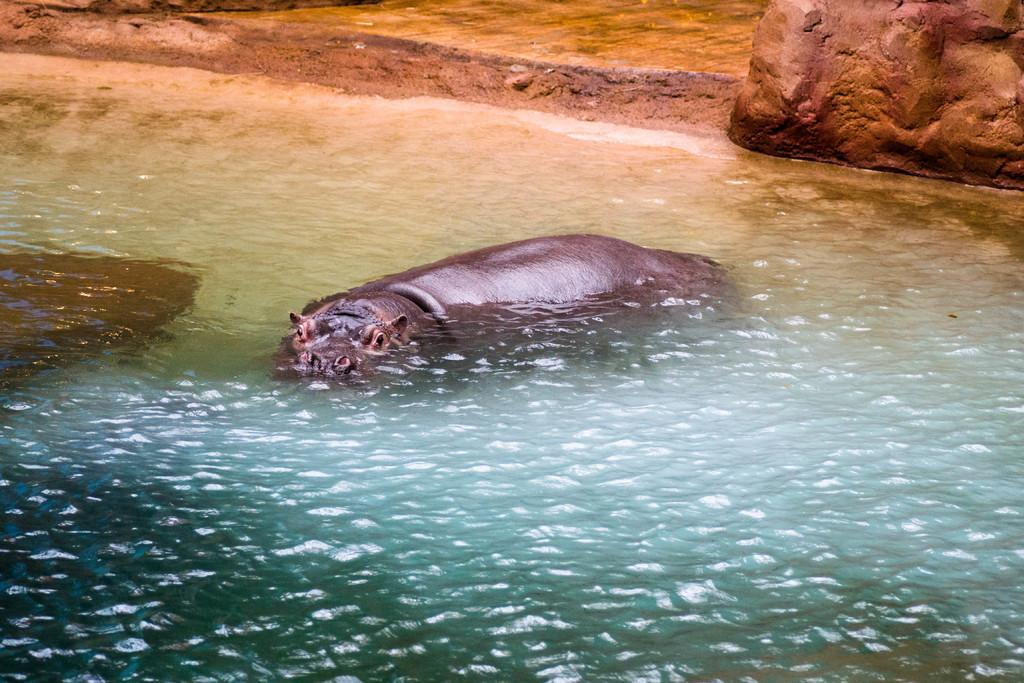What animal is in the water in the image? There is a hippopotamus in the water in the image. Where is the hippopotamus located in the image? The hippopotamus is in the middle of the image. What object can be seen on the right side of the image? There is a stone on the right side of the image. How does the hippopotamus patch the hole in the image? There is no hole in the image, and the hippopotamus is not shown performing any actions related to patching. 